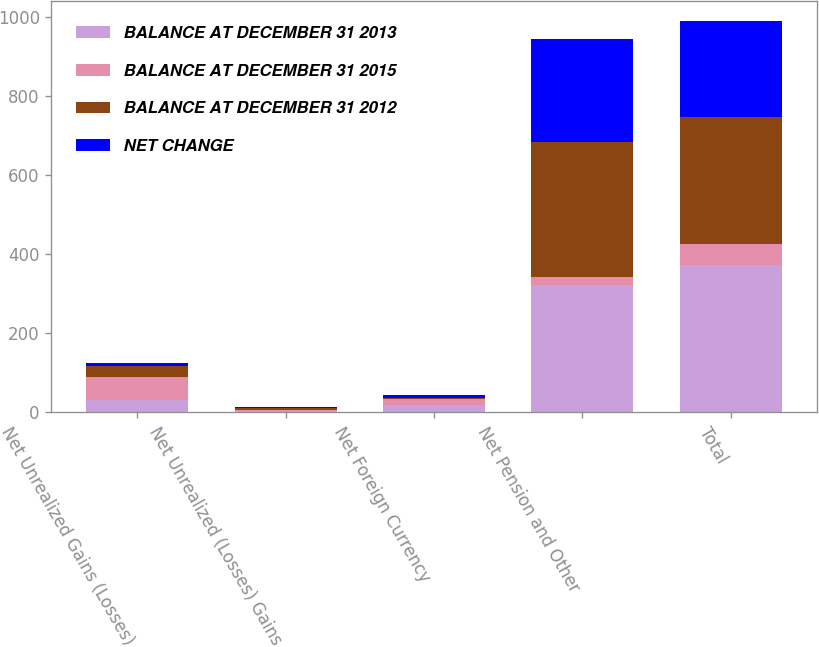Convert chart. <chart><loc_0><loc_0><loc_500><loc_500><stacked_bar_chart><ecel><fcel>Net Unrealized Gains (Losses)<fcel>Net Unrealized (Losses) Gains<fcel>Net Foreign Currency<fcel>Net Pension and Other<fcel>Total<nl><fcel>BALANCE AT DECEMBER 31 2013<fcel>31<fcel>3<fcel>17.6<fcel>321.1<fcel>372.7<nl><fcel>BALANCE AT DECEMBER 31 2015<fcel>58.6<fcel>1.7<fcel>15.9<fcel>19.8<fcel>53<nl><fcel>BALANCE AT DECEMBER 31 2012<fcel>27.6<fcel>4.7<fcel>1.7<fcel>340.9<fcel>319.7<nl><fcel>NET CHANGE<fcel>6<fcel>2.9<fcel>7.1<fcel>260.3<fcel>244.3<nl></chart> 